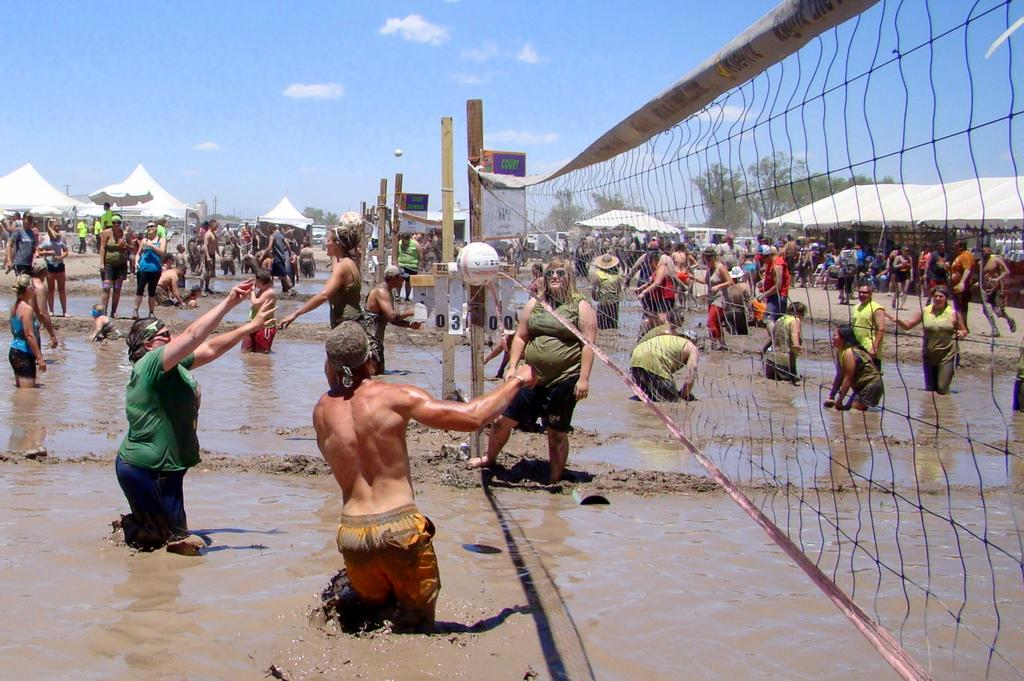Who or what can be seen in the image? There are people in the image. What objects are associated with the people in the image? There are nets with wooden poles visible in the image. What is happening with the balls in the image? There are balls in the air in the image. What is the ground like in the image? There is mud visible in the image. What structures can be seen in the background of the image? There are tents in the background of the image. What type of natural environment is visible in the background of the image? There are trees in the background of the image, and the sky is visible with clouds present. What type of trousers are the people wearing in the image? There is no information about the type of trousers the people are wearing in the image. What observation can be made about the quietness of the scene in the image? The image does not provide any information about the noise level or quietness of the scene. 